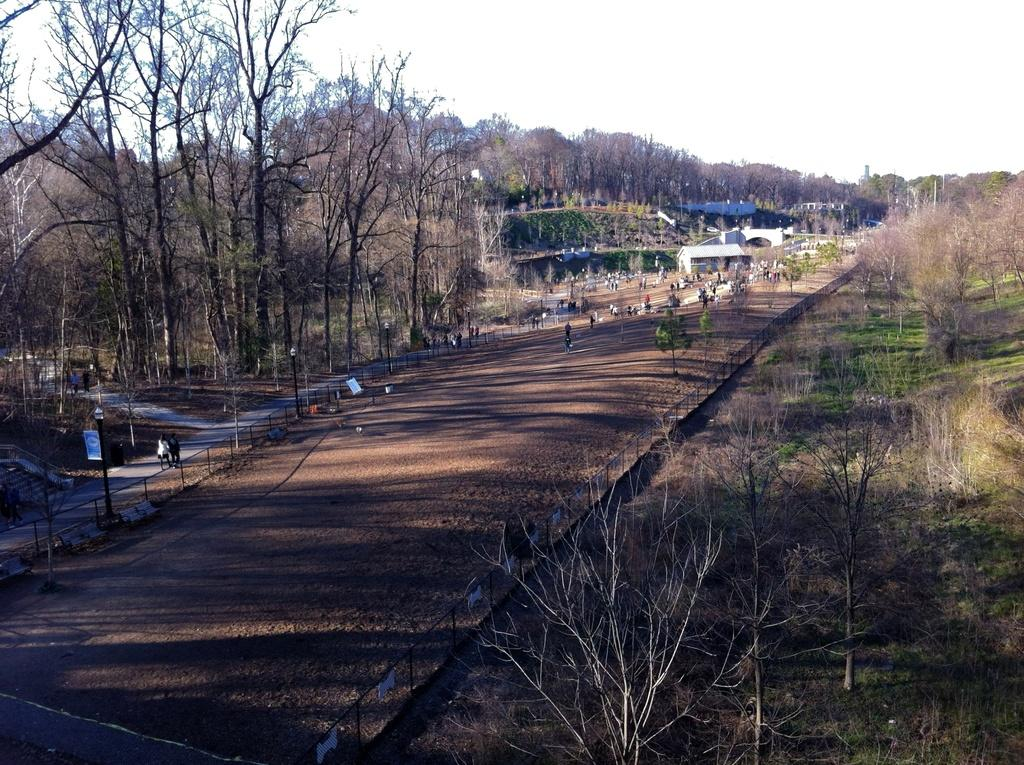What type of natural elements can be seen in the image? There are trees in the image. Can you identify any human presence in the image? Yes, there are persons in the image. What type of man-made structures are visible in the image? There are buildings in the image. What are the vertical structures in the image used for? There are poles in the image, which are likely used for support or signage. What is the primary pathway visible in the image? There is a road in the image. What other objects can be seen in the image besides the ones mentioned? There are other objects in the image, but their specific details are not provided. Where are the trees and road located in the image? Trees are at the bottom of the image, and the road is also at the bottom of the image. What part of the natural environment is visible in the image? The sky is at the top of the image. What type of flesh can be seen on the persons in the image? There is no mention of flesh or any specific body parts in the image, so it cannot be determined from the image. What type of board is being used by the persons in the image? There is no board present in the image, so it cannot be determined from the image. 